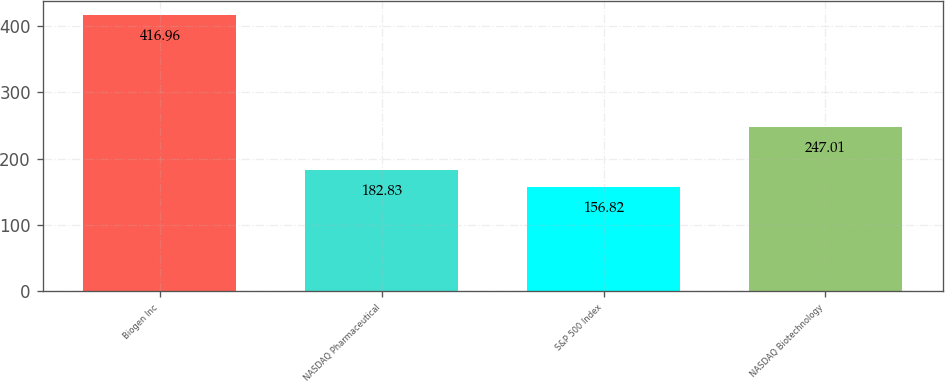Convert chart to OTSL. <chart><loc_0><loc_0><loc_500><loc_500><bar_chart><fcel>Biogen Inc<fcel>NASDAQ Pharmaceutical<fcel>S&P 500 Index<fcel>NASDAQ Biotechnology<nl><fcel>416.96<fcel>182.83<fcel>156.82<fcel>247.01<nl></chart> 